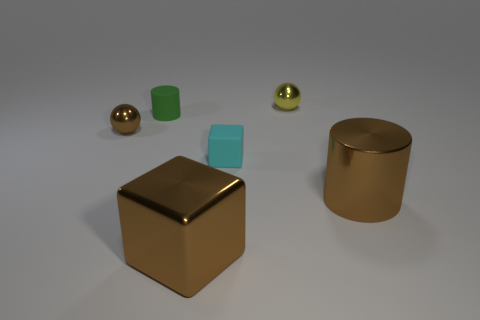Add 3 small yellow balls. How many objects exist? 9 Subtract all balls. How many objects are left? 4 Subtract all small cyan things. Subtract all brown metallic cylinders. How many objects are left? 4 Add 5 tiny green cylinders. How many tiny green cylinders are left? 6 Add 3 big cyan metal objects. How many big cyan metal objects exist? 3 Subtract 0 gray cylinders. How many objects are left? 6 